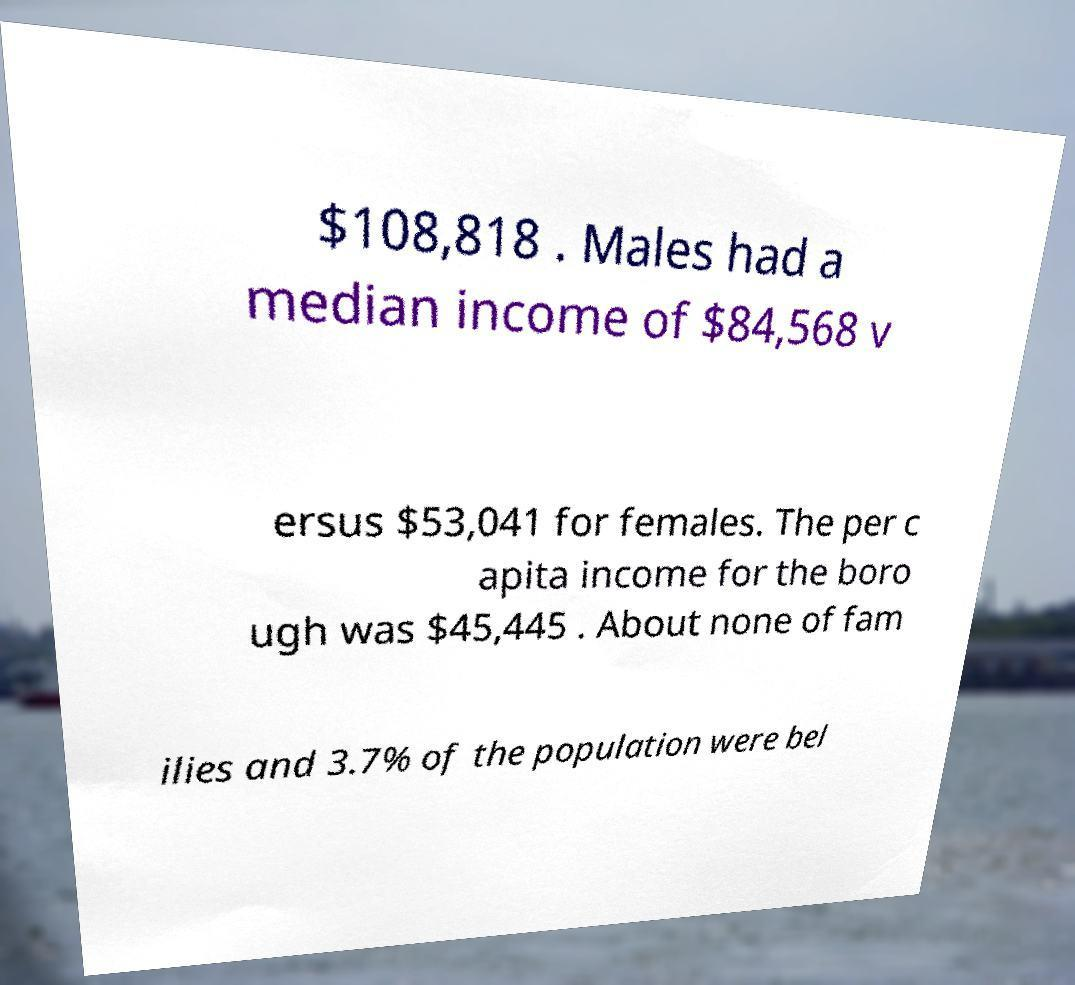Can you accurately transcribe the text from the provided image for me? $108,818 . Males had a median income of $84,568 v ersus $53,041 for females. The per c apita income for the boro ugh was $45,445 . About none of fam ilies and 3.7% of the population were bel 